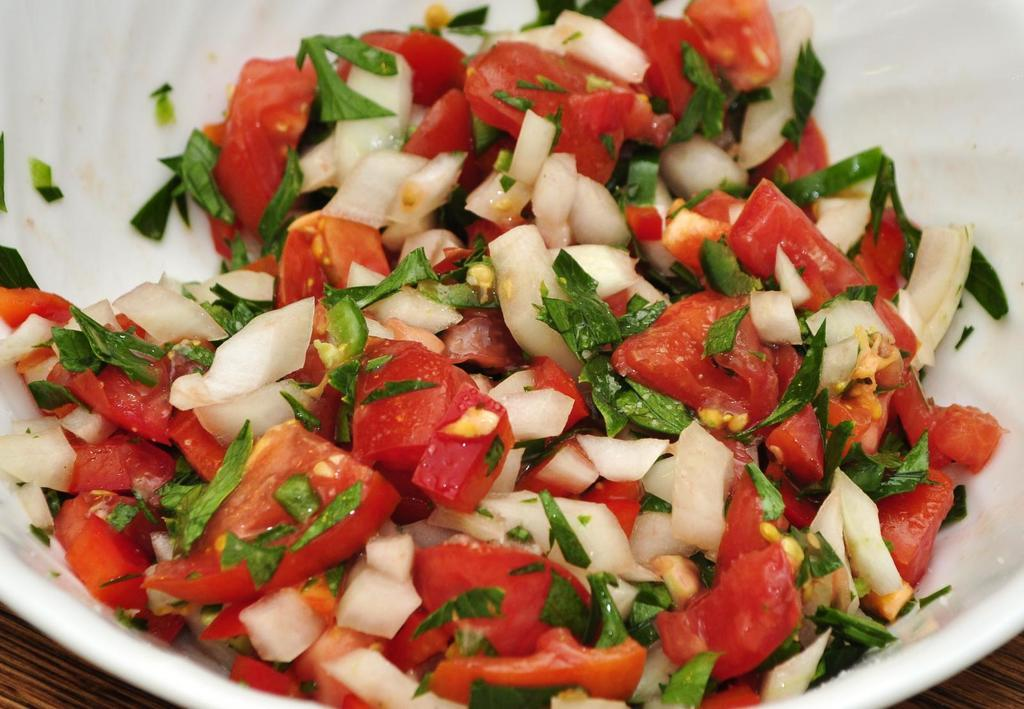What color is the bowl in the image? The bowl in the image is white. What is inside the bowl? The bowl contains a salad. On what surface is the bowl placed? The bowl is placed on a wooden surface. What nation's flag is depicted on the salad in the image? There is no flag or nation mentioned in the image; the image only shows a white bowl containing a salad placed on a wooden surface. 